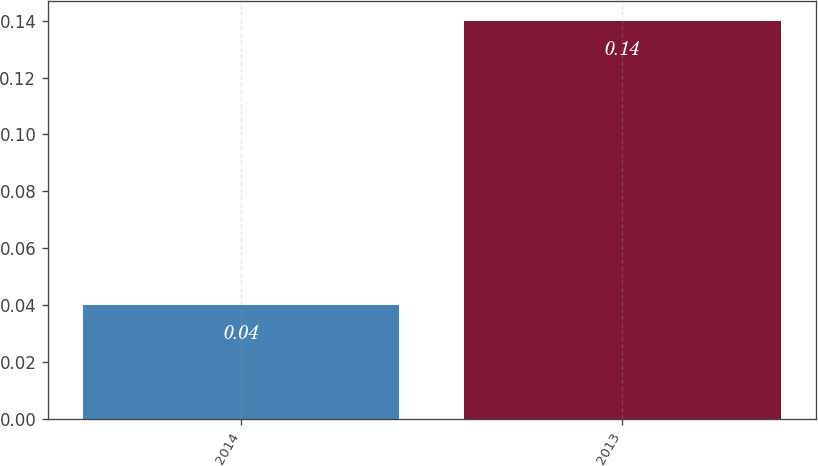Convert chart. <chart><loc_0><loc_0><loc_500><loc_500><bar_chart><fcel>2014<fcel>2013<nl><fcel>0.04<fcel>0.14<nl></chart> 